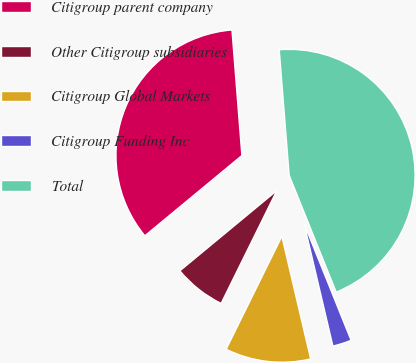Convert chart. <chart><loc_0><loc_0><loc_500><loc_500><pie_chart><fcel>Citigroup parent company<fcel>Other Citigroup subsidiaries<fcel>Citigroup Global Markets<fcel>Citigroup Funding Inc<fcel>Total<nl><fcel>34.75%<fcel>6.7%<fcel>10.97%<fcel>2.42%<fcel>45.17%<nl></chart> 